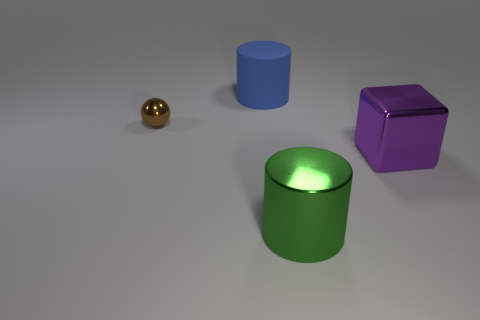Add 1 purple rubber blocks. How many objects exist? 5 Subtract all spheres. How many objects are left? 3 Subtract 0 cyan balls. How many objects are left? 4 Subtract all cyan cubes. Subtract all large green cylinders. How many objects are left? 3 Add 2 big matte cylinders. How many big matte cylinders are left? 3 Add 4 gray metallic things. How many gray metallic things exist? 4 